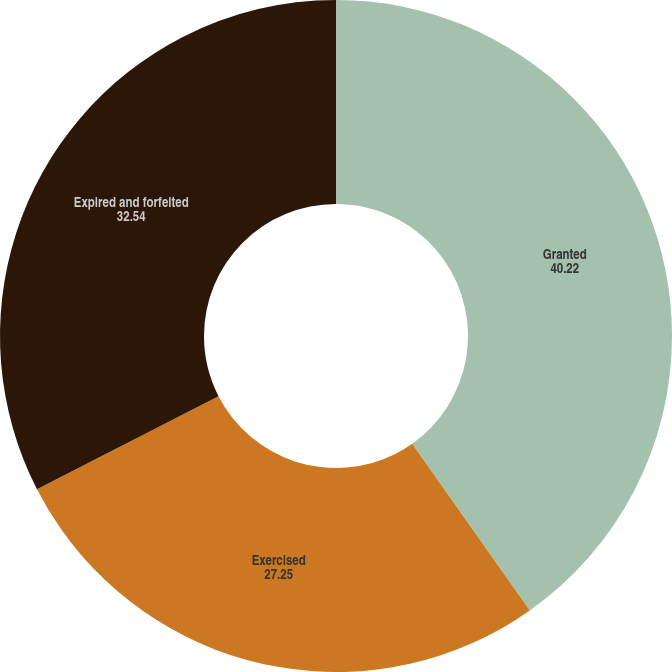<chart> <loc_0><loc_0><loc_500><loc_500><pie_chart><fcel>Granted<fcel>Exercised<fcel>Expired and forfeited<nl><fcel>40.22%<fcel>27.25%<fcel>32.54%<nl></chart> 